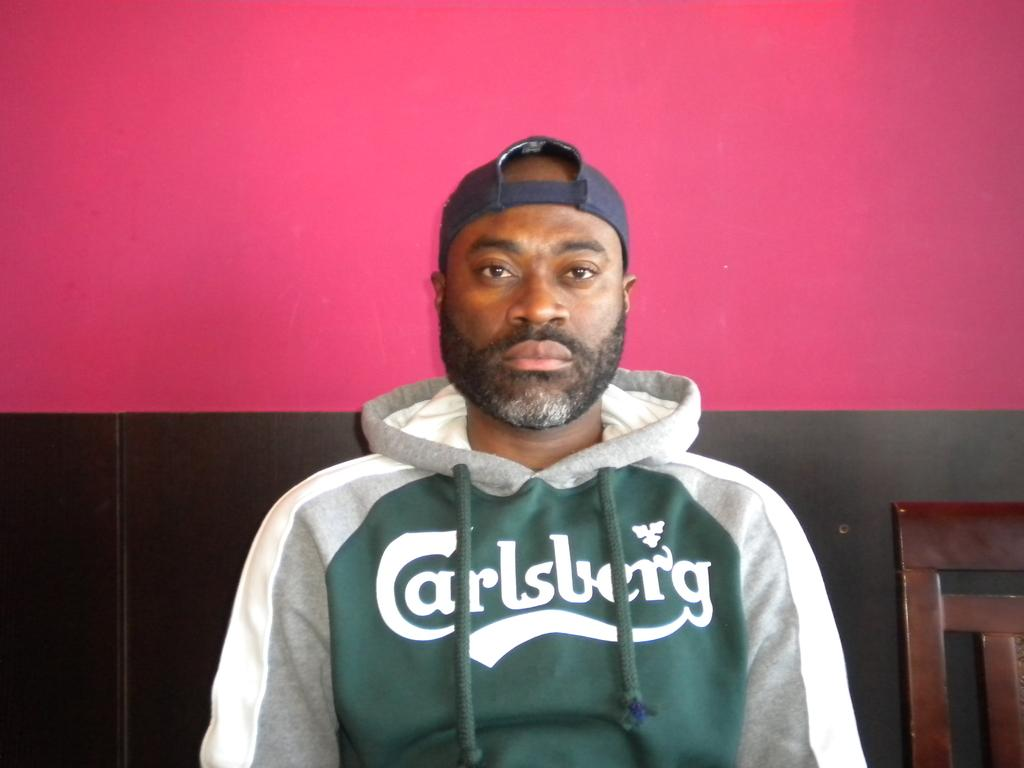<image>
Relay a brief, clear account of the picture shown. A man with a beard and black hat wearing a Carlsberg sweater. 